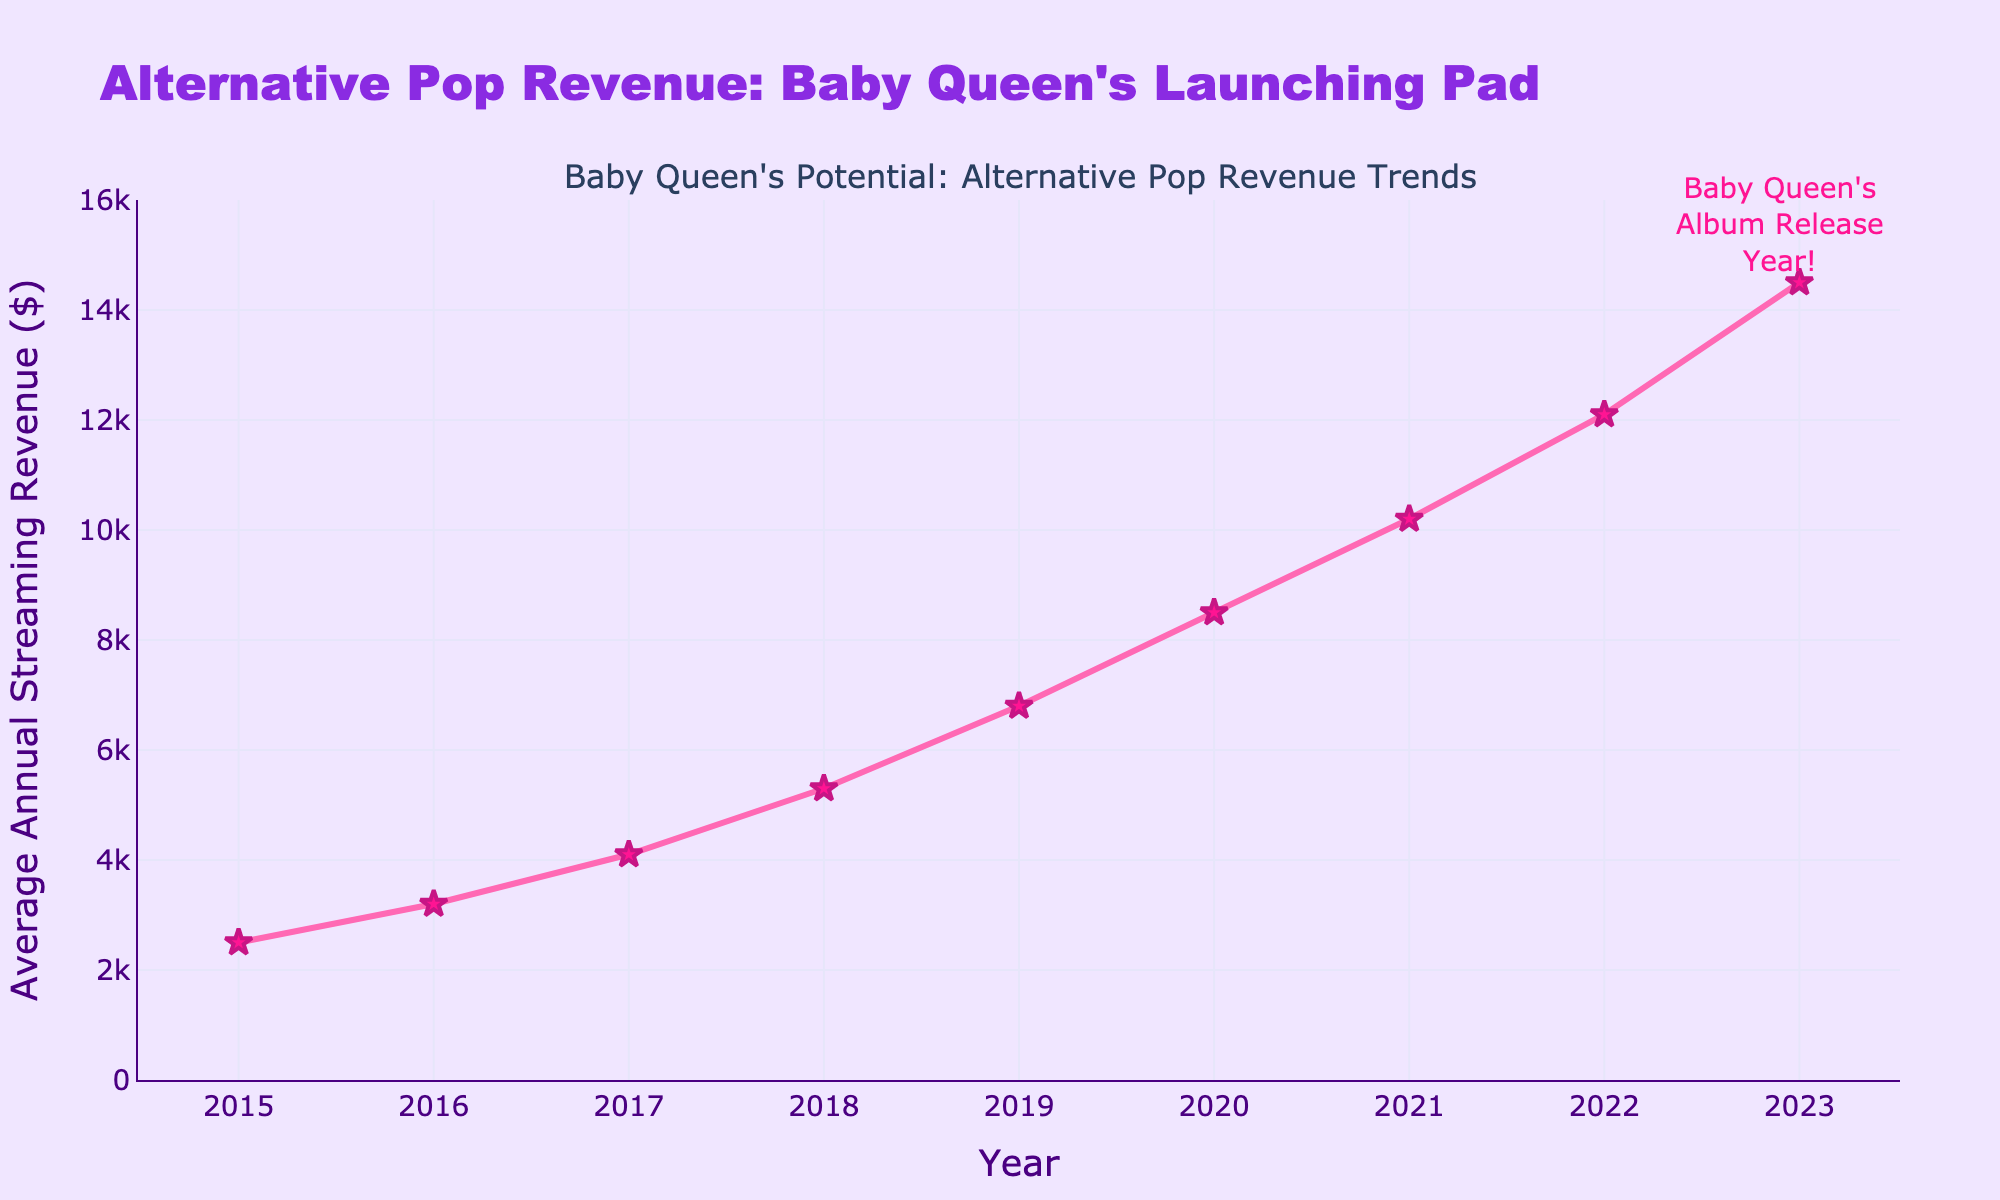What is the average annual streaming revenue in 2017? The figure indicates that the average annual streaming revenue in 2017 is represented by a star marker. According to the y-axis, it is $4,100.
Answer: $4,100 Which year had a higher average annual streaming revenue, 2018 or 2019? To compare the two years, check the y-axis values for both years. In 2018, the revenue is $5,300, and in 2019, it is $6,800. 2019 has a higher revenue.
Answer: 2019 By how much did the average annual streaming revenue increase from 2016 to 2023? Calculate the difference in the y-axis values between these years. In 2016, the revenue is $3,200, and in 2023, it is $14,500. The increase is $14,500 - $3,200 = $11,300.
Answer: $11,300 Is the trend of the average annual streaming revenue increasing or decreasing over the years displayed in the chart? Observing the line graph, the average annual streaming revenue increases consistently from 2015 to 2023.
Answer: Increasing What is the visual indication for Baby Queen's album release year? The annotation on the plot points to 2023 with a text mentioning "Baby Queen's Album Release Year!"
Answer: Annotation at 2023 How many years did it take for the average annual streaming revenue to surpass $10,000? Starting from 2015, the revenue surpasses $10,000 in 2021. Therefore, it took 2021 - 2015 = 6 years.
Answer: 6 years What's the total average annual streaming revenue for the years 2020, 2021, and 2022? Add the revenues for these years: $8,500 (2020) + $10,200 (2021) + $12,100 (2022) = $30,800.
Answer: $30,800 In which year was the average annual streaming revenue closest to the midpoint between the revenues of 2015 and 2023? The midpoint revenue is ($2,500 + $14,500) / 2 = $8,500. 2020 has a revenue of $8,500, exactly equal to the midpoint.
Answer: 2020 Which year showed a more significant increase in average annual streaming revenue: 2017 to 2018 or 2019 to 2020? Calculate the increase for both intervals: From 2017 ($4,100) to 2018 ($5,300) is $5,300 - $4,100 = $1,200. From 2019 ($6,800) to 2020 ($8,500) is $8,500 - $6,800 = $1,700. The increase from 2019 to 2020 is more significant.
Answer: 2019 to 2020 